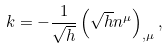Convert formula to latex. <formula><loc_0><loc_0><loc_500><loc_500>k = - \frac { 1 } { \sqrt { h } } \left ( \sqrt { h } n ^ { \mu } \right ) _ { , \mu } ,</formula> 